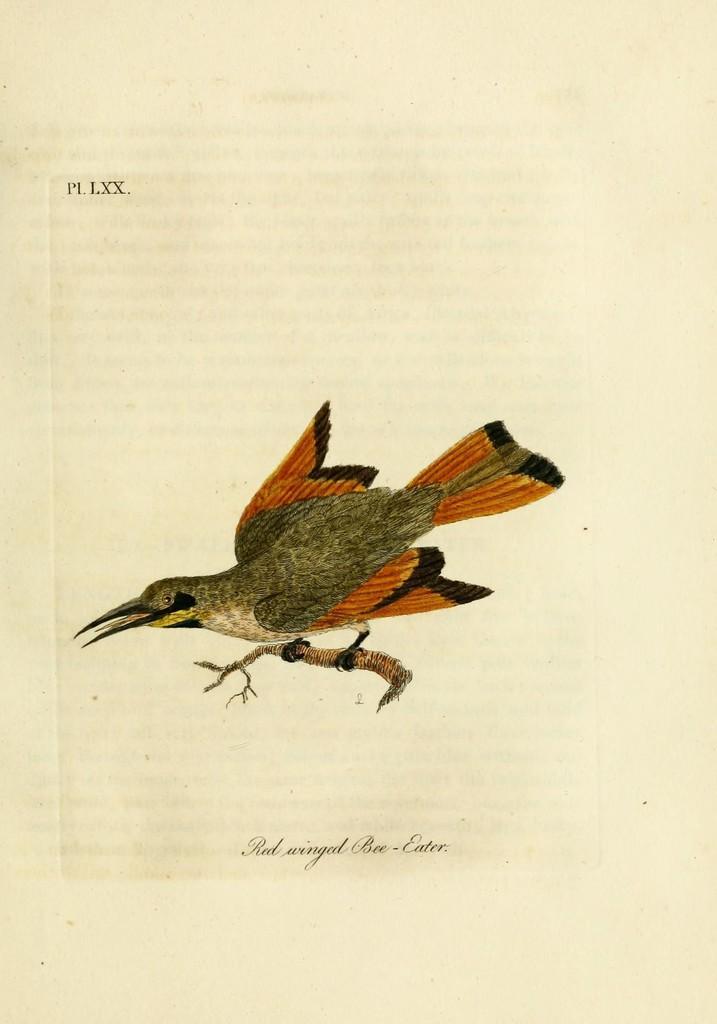Describe this image in one or two sentences. This image consists of a paper on which there is a picture of a bird along with a stem. The bird is in orange and brown color. And there is a text on the paper. 